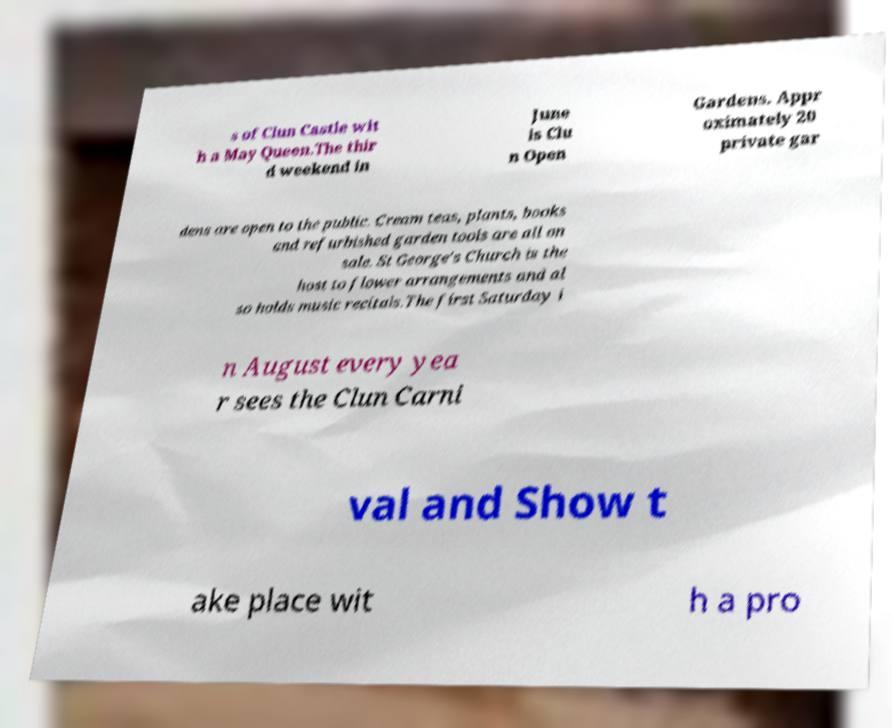Can you read and provide the text displayed in the image?This photo seems to have some interesting text. Can you extract and type it out for me? s of Clun Castle wit h a May Queen.The thir d weekend in June is Clu n Open Gardens. Appr oximately 20 private gar dens are open to the public. Cream teas, plants, books and refurbished garden tools are all on sale. St George's Church is the host to flower arrangements and al so holds music recitals.The first Saturday i n August every yea r sees the Clun Carni val and Show t ake place wit h a pro 